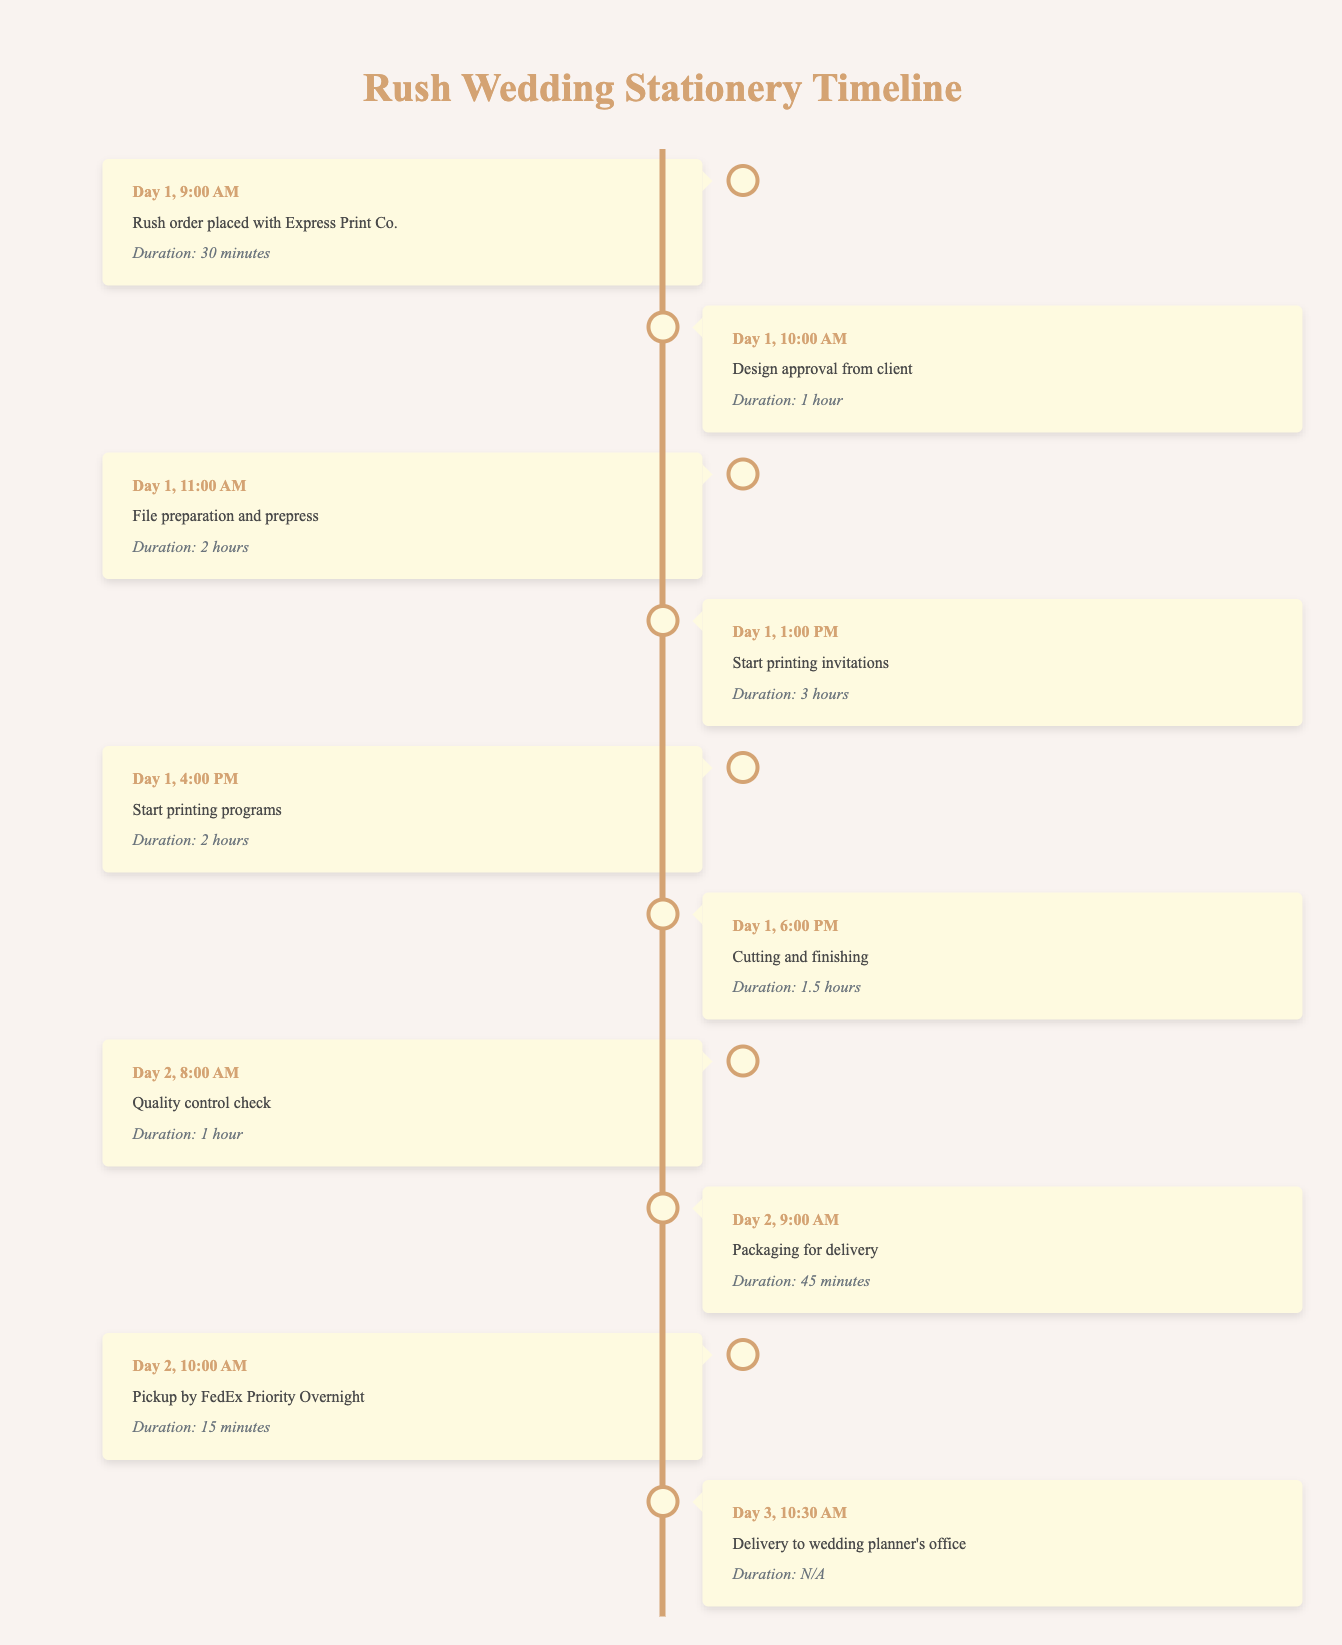What time was the rush order placed with Express Print Co.? According to the timeline table, the rush order was placed at "Day 1, 9:00 AM". This information is found in the first event of the timeline.
Answer: Day 1, 9:00 AM How long did the cutting and finishing take? The cutting and finishing process took "1.5 hours", as specified in the sixth event of the timeline.
Answer: 1.5 hours Did the quality control check happen before or after packaging for delivery? The quality control check took place at "Day 2, 8:00 AM" while packaging for delivery happened at "Day 2, 9:00 AM". Since 8:00 AM is earlier than 9:00 AM, the quality control check occurred prior to packaging.
Answer: Before What is the total duration for printing both invitations and programs? The printing of invitations started at "Day 1, 1:00 PM" and lasted for "3 hours", and printing programs started at "Day 1, 4:00 PM" for "2 hours". Thus, the total time is 3 hours + 2 hours = 5 hours.
Answer: 5 hours What event follows the design approval? The event that follows the design approval at "Day 1, 10:00 AM" is "File preparation and prepress", which starts at "Day 1, 11:00 AM". This can be derived by looking at the events in chronological order.
Answer: File preparation and prepress How much time elapses between the start of printing invitations and the quality control check? The invitations start printing at "Day 1, 1:00 PM" and the quality control check occurs at "Day 2, 8:00 AM". The time difference is 20 hours from 1:00 PM on Day 1 to 8:00 AM on Day 2.
Answer: 20 hours Is it true that the last event of the timeline is the delivery to the wedding planner's office? Yes, the last recorded event in the timeline is "Delivery to wedding planner's office" at "Day 3, 10:30 AM". Therefore, this statement is true based on the data provided.
Answer: Yes What is the first event of the second day? The first event recorded on Day 2 is "Quality control check" at "8:00 AM". This can be confirmed by reviewing the events of Day 2 in the timeline.
Answer: Quality control check How many total hours does the entire process from placing the order to delivery take? The order begins at "Day 1, 9:00 AM" and concludes with delivery at "Day 3, 10:30 AM". From Day 1 to Day 3 is a span of 2 days and 1.5 hours (from 9:00 AM to 10:30 AM). This totals to 48 hours (2 days) + 1.5 hours = 49.5 hours.
Answer: 49.5 hours 